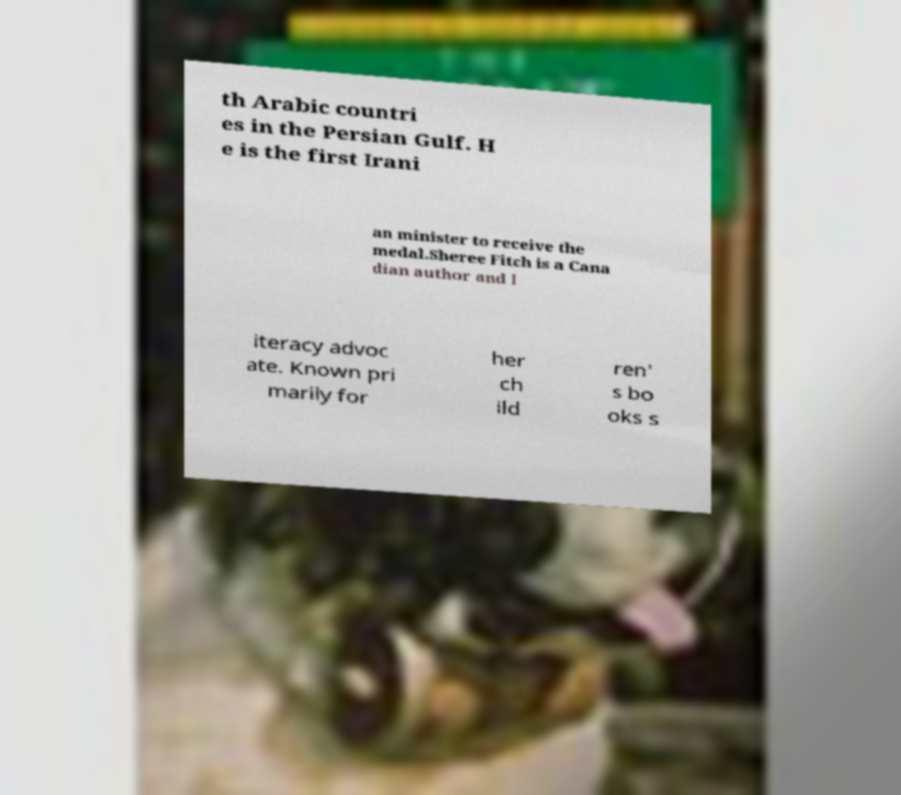There's text embedded in this image that I need extracted. Can you transcribe it verbatim? th Arabic countri es in the Persian Gulf. H e is the first Irani an minister to receive the medal.Sheree Fitch is a Cana dian author and l iteracy advoc ate. Known pri marily for her ch ild ren' s bo oks s 